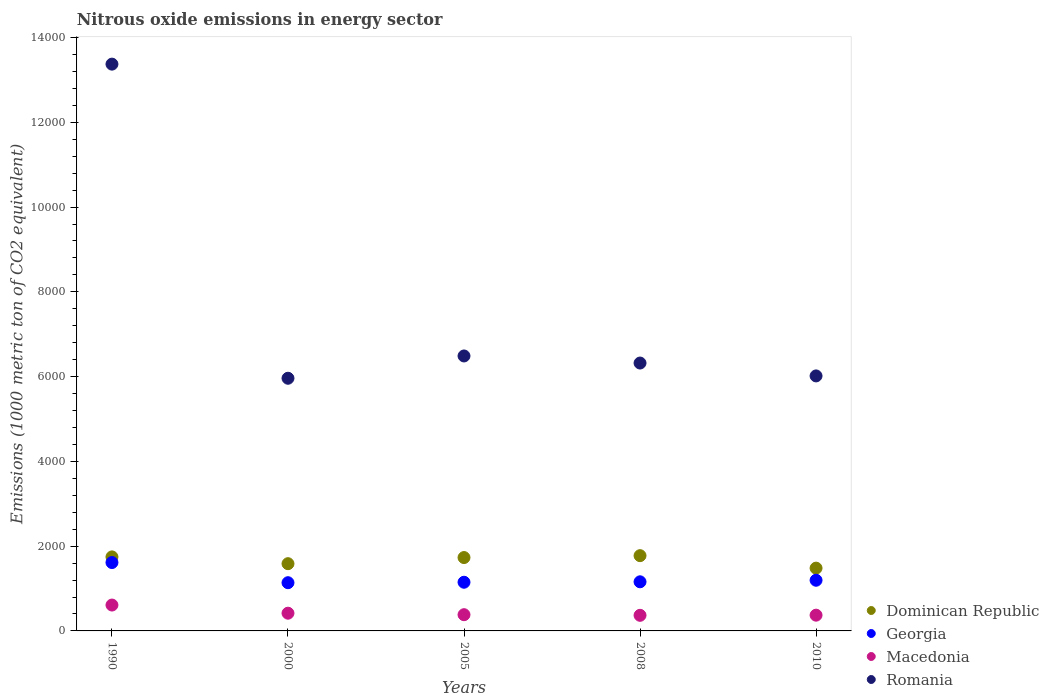What is the amount of nitrous oxide emitted in Macedonia in 2000?
Your answer should be compact. 418.3. Across all years, what is the maximum amount of nitrous oxide emitted in Macedonia?
Keep it short and to the point. 610.4. Across all years, what is the minimum amount of nitrous oxide emitted in Macedonia?
Ensure brevity in your answer.  368. In which year was the amount of nitrous oxide emitted in Georgia minimum?
Offer a very short reply. 2000. What is the total amount of nitrous oxide emitted in Macedonia in the graph?
Make the answer very short. 2151.1. What is the difference between the amount of nitrous oxide emitted in Georgia in 1990 and that in 2010?
Make the answer very short. 417.8. What is the difference between the amount of nitrous oxide emitted in Macedonia in 2000 and the amount of nitrous oxide emitted in Georgia in 2010?
Keep it short and to the point. -777.3. What is the average amount of nitrous oxide emitted in Dominican Republic per year?
Your answer should be compact. 1664.22. In the year 2010, what is the difference between the amount of nitrous oxide emitted in Georgia and amount of nitrous oxide emitted in Macedonia?
Your answer should be compact. 824. What is the ratio of the amount of nitrous oxide emitted in Georgia in 2005 to that in 2008?
Give a very brief answer. 0.99. Is the difference between the amount of nitrous oxide emitted in Georgia in 2005 and 2008 greater than the difference between the amount of nitrous oxide emitted in Macedonia in 2005 and 2008?
Keep it short and to the point. No. What is the difference between the highest and the second highest amount of nitrous oxide emitted in Romania?
Make the answer very short. 6885. What is the difference between the highest and the lowest amount of nitrous oxide emitted in Macedonia?
Make the answer very short. 242.4. In how many years, is the amount of nitrous oxide emitted in Dominican Republic greater than the average amount of nitrous oxide emitted in Dominican Republic taken over all years?
Your answer should be compact. 3. Is it the case that in every year, the sum of the amount of nitrous oxide emitted in Georgia and amount of nitrous oxide emitted in Dominican Republic  is greater than the sum of amount of nitrous oxide emitted in Macedonia and amount of nitrous oxide emitted in Romania?
Ensure brevity in your answer.  Yes. Is the amount of nitrous oxide emitted in Romania strictly less than the amount of nitrous oxide emitted in Dominican Republic over the years?
Your answer should be compact. No. How many years are there in the graph?
Your response must be concise. 5. Are the values on the major ticks of Y-axis written in scientific E-notation?
Offer a terse response. No. Does the graph contain grids?
Give a very brief answer. No. How are the legend labels stacked?
Make the answer very short. Vertical. What is the title of the graph?
Your answer should be very brief. Nitrous oxide emissions in energy sector. What is the label or title of the Y-axis?
Your response must be concise. Emissions (1000 metric ton of CO2 equivalent). What is the Emissions (1000 metric ton of CO2 equivalent) of Dominican Republic in 1990?
Your answer should be compact. 1746.5. What is the Emissions (1000 metric ton of CO2 equivalent) in Georgia in 1990?
Offer a very short reply. 1613.4. What is the Emissions (1000 metric ton of CO2 equivalent) in Macedonia in 1990?
Provide a short and direct response. 610.4. What is the Emissions (1000 metric ton of CO2 equivalent) in Romania in 1990?
Provide a short and direct response. 1.34e+04. What is the Emissions (1000 metric ton of CO2 equivalent) in Dominican Republic in 2000?
Provide a succinct answer. 1586.4. What is the Emissions (1000 metric ton of CO2 equivalent) of Georgia in 2000?
Give a very brief answer. 1137.6. What is the Emissions (1000 metric ton of CO2 equivalent) of Macedonia in 2000?
Keep it short and to the point. 418.3. What is the Emissions (1000 metric ton of CO2 equivalent) in Romania in 2000?
Provide a succinct answer. 5961.2. What is the Emissions (1000 metric ton of CO2 equivalent) in Dominican Republic in 2005?
Offer a terse response. 1731. What is the Emissions (1000 metric ton of CO2 equivalent) in Georgia in 2005?
Your answer should be very brief. 1148.6. What is the Emissions (1000 metric ton of CO2 equivalent) of Macedonia in 2005?
Provide a short and direct response. 382.8. What is the Emissions (1000 metric ton of CO2 equivalent) of Romania in 2005?
Your response must be concise. 6487.3. What is the Emissions (1000 metric ton of CO2 equivalent) of Dominican Republic in 2008?
Your answer should be very brief. 1775.7. What is the Emissions (1000 metric ton of CO2 equivalent) in Georgia in 2008?
Provide a short and direct response. 1158.8. What is the Emissions (1000 metric ton of CO2 equivalent) of Macedonia in 2008?
Offer a very short reply. 368. What is the Emissions (1000 metric ton of CO2 equivalent) in Romania in 2008?
Keep it short and to the point. 6320.1. What is the Emissions (1000 metric ton of CO2 equivalent) of Dominican Republic in 2010?
Provide a short and direct response. 1481.5. What is the Emissions (1000 metric ton of CO2 equivalent) in Georgia in 2010?
Provide a short and direct response. 1195.6. What is the Emissions (1000 metric ton of CO2 equivalent) of Macedonia in 2010?
Your answer should be very brief. 371.6. What is the Emissions (1000 metric ton of CO2 equivalent) of Romania in 2010?
Make the answer very short. 6016.4. Across all years, what is the maximum Emissions (1000 metric ton of CO2 equivalent) in Dominican Republic?
Make the answer very short. 1775.7. Across all years, what is the maximum Emissions (1000 metric ton of CO2 equivalent) of Georgia?
Your response must be concise. 1613.4. Across all years, what is the maximum Emissions (1000 metric ton of CO2 equivalent) of Macedonia?
Ensure brevity in your answer.  610.4. Across all years, what is the maximum Emissions (1000 metric ton of CO2 equivalent) in Romania?
Make the answer very short. 1.34e+04. Across all years, what is the minimum Emissions (1000 metric ton of CO2 equivalent) of Dominican Republic?
Keep it short and to the point. 1481.5. Across all years, what is the minimum Emissions (1000 metric ton of CO2 equivalent) of Georgia?
Provide a short and direct response. 1137.6. Across all years, what is the minimum Emissions (1000 metric ton of CO2 equivalent) in Macedonia?
Ensure brevity in your answer.  368. Across all years, what is the minimum Emissions (1000 metric ton of CO2 equivalent) in Romania?
Your answer should be very brief. 5961.2. What is the total Emissions (1000 metric ton of CO2 equivalent) of Dominican Republic in the graph?
Your response must be concise. 8321.1. What is the total Emissions (1000 metric ton of CO2 equivalent) in Georgia in the graph?
Offer a very short reply. 6254. What is the total Emissions (1000 metric ton of CO2 equivalent) of Macedonia in the graph?
Give a very brief answer. 2151.1. What is the total Emissions (1000 metric ton of CO2 equivalent) of Romania in the graph?
Your answer should be compact. 3.82e+04. What is the difference between the Emissions (1000 metric ton of CO2 equivalent) of Dominican Republic in 1990 and that in 2000?
Keep it short and to the point. 160.1. What is the difference between the Emissions (1000 metric ton of CO2 equivalent) of Georgia in 1990 and that in 2000?
Provide a succinct answer. 475.8. What is the difference between the Emissions (1000 metric ton of CO2 equivalent) of Macedonia in 1990 and that in 2000?
Offer a terse response. 192.1. What is the difference between the Emissions (1000 metric ton of CO2 equivalent) of Romania in 1990 and that in 2000?
Ensure brevity in your answer.  7411.1. What is the difference between the Emissions (1000 metric ton of CO2 equivalent) of Georgia in 1990 and that in 2005?
Give a very brief answer. 464.8. What is the difference between the Emissions (1000 metric ton of CO2 equivalent) in Macedonia in 1990 and that in 2005?
Give a very brief answer. 227.6. What is the difference between the Emissions (1000 metric ton of CO2 equivalent) in Romania in 1990 and that in 2005?
Give a very brief answer. 6885. What is the difference between the Emissions (1000 metric ton of CO2 equivalent) in Dominican Republic in 1990 and that in 2008?
Your response must be concise. -29.2. What is the difference between the Emissions (1000 metric ton of CO2 equivalent) in Georgia in 1990 and that in 2008?
Give a very brief answer. 454.6. What is the difference between the Emissions (1000 metric ton of CO2 equivalent) in Macedonia in 1990 and that in 2008?
Your response must be concise. 242.4. What is the difference between the Emissions (1000 metric ton of CO2 equivalent) of Romania in 1990 and that in 2008?
Offer a very short reply. 7052.2. What is the difference between the Emissions (1000 metric ton of CO2 equivalent) in Dominican Republic in 1990 and that in 2010?
Offer a terse response. 265. What is the difference between the Emissions (1000 metric ton of CO2 equivalent) in Georgia in 1990 and that in 2010?
Provide a succinct answer. 417.8. What is the difference between the Emissions (1000 metric ton of CO2 equivalent) in Macedonia in 1990 and that in 2010?
Offer a very short reply. 238.8. What is the difference between the Emissions (1000 metric ton of CO2 equivalent) of Romania in 1990 and that in 2010?
Provide a short and direct response. 7355.9. What is the difference between the Emissions (1000 metric ton of CO2 equivalent) of Dominican Republic in 2000 and that in 2005?
Keep it short and to the point. -144.6. What is the difference between the Emissions (1000 metric ton of CO2 equivalent) in Georgia in 2000 and that in 2005?
Your answer should be very brief. -11. What is the difference between the Emissions (1000 metric ton of CO2 equivalent) in Macedonia in 2000 and that in 2005?
Your answer should be very brief. 35.5. What is the difference between the Emissions (1000 metric ton of CO2 equivalent) of Romania in 2000 and that in 2005?
Provide a succinct answer. -526.1. What is the difference between the Emissions (1000 metric ton of CO2 equivalent) in Dominican Republic in 2000 and that in 2008?
Provide a succinct answer. -189.3. What is the difference between the Emissions (1000 metric ton of CO2 equivalent) in Georgia in 2000 and that in 2008?
Offer a very short reply. -21.2. What is the difference between the Emissions (1000 metric ton of CO2 equivalent) in Macedonia in 2000 and that in 2008?
Give a very brief answer. 50.3. What is the difference between the Emissions (1000 metric ton of CO2 equivalent) of Romania in 2000 and that in 2008?
Make the answer very short. -358.9. What is the difference between the Emissions (1000 metric ton of CO2 equivalent) of Dominican Republic in 2000 and that in 2010?
Provide a succinct answer. 104.9. What is the difference between the Emissions (1000 metric ton of CO2 equivalent) in Georgia in 2000 and that in 2010?
Your answer should be very brief. -58. What is the difference between the Emissions (1000 metric ton of CO2 equivalent) in Macedonia in 2000 and that in 2010?
Offer a very short reply. 46.7. What is the difference between the Emissions (1000 metric ton of CO2 equivalent) of Romania in 2000 and that in 2010?
Your answer should be compact. -55.2. What is the difference between the Emissions (1000 metric ton of CO2 equivalent) in Dominican Republic in 2005 and that in 2008?
Ensure brevity in your answer.  -44.7. What is the difference between the Emissions (1000 metric ton of CO2 equivalent) in Georgia in 2005 and that in 2008?
Your answer should be very brief. -10.2. What is the difference between the Emissions (1000 metric ton of CO2 equivalent) of Romania in 2005 and that in 2008?
Make the answer very short. 167.2. What is the difference between the Emissions (1000 metric ton of CO2 equivalent) of Dominican Republic in 2005 and that in 2010?
Your response must be concise. 249.5. What is the difference between the Emissions (1000 metric ton of CO2 equivalent) of Georgia in 2005 and that in 2010?
Offer a terse response. -47. What is the difference between the Emissions (1000 metric ton of CO2 equivalent) of Romania in 2005 and that in 2010?
Make the answer very short. 470.9. What is the difference between the Emissions (1000 metric ton of CO2 equivalent) in Dominican Republic in 2008 and that in 2010?
Provide a succinct answer. 294.2. What is the difference between the Emissions (1000 metric ton of CO2 equivalent) in Georgia in 2008 and that in 2010?
Ensure brevity in your answer.  -36.8. What is the difference between the Emissions (1000 metric ton of CO2 equivalent) in Macedonia in 2008 and that in 2010?
Offer a very short reply. -3.6. What is the difference between the Emissions (1000 metric ton of CO2 equivalent) in Romania in 2008 and that in 2010?
Provide a short and direct response. 303.7. What is the difference between the Emissions (1000 metric ton of CO2 equivalent) of Dominican Republic in 1990 and the Emissions (1000 metric ton of CO2 equivalent) of Georgia in 2000?
Your answer should be very brief. 608.9. What is the difference between the Emissions (1000 metric ton of CO2 equivalent) in Dominican Republic in 1990 and the Emissions (1000 metric ton of CO2 equivalent) in Macedonia in 2000?
Provide a succinct answer. 1328.2. What is the difference between the Emissions (1000 metric ton of CO2 equivalent) of Dominican Republic in 1990 and the Emissions (1000 metric ton of CO2 equivalent) of Romania in 2000?
Your answer should be very brief. -4214.7. What is the difference between the Emissions (1000 metric ton of CO2 equivalent) of Georgia in 1990 and the Emissions (1000 metric ton of CO2 equivalent) of Macedonia in 2000?
Provide a succinct answer. 1195.1. What is the difference between the Emissions (1000 metric ton of CO2 equivalent) in Georgia in 1990 and the Emissions (1000 metric ton of CO2 equivalent) in Romania in 2000?
Your answer should be compact. -4347.8. What is the difference between the Emissions (1000 metric ton of CO2 equivalent) of Macedonia in 1990 and the Emissions (1000 metric ton of CO2 equivalent) of Romania in 2000?
Provide a succinct answer. -5350.8. What is the difference between the Emissions (1000 metric ton of CO2 equivalent) of Dominican Republic in 1990 and the Emissions (1000 metric ton of CO2 equivalent) of Georgia in 2005?
Offer a terse response. 597.9. What is the difference between the Emissions (1000 metric ton of CO2 equivalent) of Dominican Republic in 1990 and the Emissions (1000 metric ton of CO2 equivalent) of Macedonia in 2005?
Make the answer very short. 1363.7. What is the difference between the Emissions (1000 metric ton of CO2 equivalent) of Dominican Republic in 1990 and the Emissions (1000 metric ton of CO2 equivalent) of Romania in 2005?
Make the answer very short. -4740.8. What is the difference between the Emissions (1000 metric ton of CO2 equivalent) of Georgia in 1990 and the Emissions (1000 metric ton of CO2 equivalent) of Macedonia in 2005?
Your answer should be very brief. 1230.6. What is the difference between the Emissions (1000 metric ton of CO2 equivalent) of Georgia in 1990 and the Emissions (1000 metric ton of CO2 equivalent) of Romania in 2005?
Your answer should be very brief. -4873.9. What is the difference between the Emissions (1000 metric ton of CO2 equivalent) of Macedonia in 1990 and the Emissions (1000 metric ton of CO2 equivalent) of Romania in 2005?
Keep it short and to the point. -5876.9. What is the difference between the Emissions (1000 metric ton of CO2 equivalent) in Dominican Republic in 1990 and the Emissions (1000 metric ton of CO2 equivalent) in Georgia in 2008?
Your response must be concise. 587.7. What is the difference between the Emissions (1000 metric ton of CO2 equivalent) in Dominican Republic in 1990 and the Emissions (1000 metric ton of CO2 equivalent) in Macedonia in 2008?
Provide a short and direct response. 1378.5. What is the difference between the Emissions (1000 metric ton of CO2 equivalent) in Dominican Republic in 1990 and the Emissions (1000 metric ton of CO2 equivalent) in Romania in 2008?
Your response must be concise. -4573.6. What is the difference between the Emissions (1000 metric ton of CO2 equivalent) in Georgia in 1990 and the Emissions (1000 metric ton of CO2 equivalent) in Macedonia in 2008?
Give a very brief answer. 1245.4. What is the difference between the Emissions (1000 metric ton of CO2 equivalent) of Georgia in 1990 and the Emissions (1000 metric ton of CO2 equivalent) of Romania in 2008?
Give a very brief answer. -4706.7. What is the difference between the Emissions (1000 metric ton of CO2 equivalent) of Macedonia in 1990 and the Emissions (1000 metric ton of CO2 equivalent) of Romania in 2008?
Offer a terse response. -5709.7. What is the difference between the Emissions (1000 metric ton of CO2 equivalent) in Dominican Republic in 1990 and the Emissions (1000 metric ton of CO2 equivalent) in Georgia in 2010?
Your response must be concise. 550.9. What is the difference between the Emissions (1000 metric ton of CO2 equivalent) in Dominican Republic in 1990 and the Emissions (1000 metric ton of CO2 equivalent) in Macedonia in 2010?
Make the answer very short. 1374.9. What is the difference between the Emissions (1000 metric ton of CO2 equivalent) of Dominican Republic in 1990 and the Emissions (1000 metric ton of CO2 equivalent) of Romania in 2010?
Provide a short and direct response. -4269.9. What is the difference between the Emissions (1000 metric ton of CO2 equivalent) of Georgia in 1990 and the Emissions (1000 metric ton of CO2 equivalent) of Macedonia in 2010?
Provide a succinct answer. 1241.8. What is the difference between the Emissions (1000 metric ton of CO2 equivalent) of Georgia in 1990 and the Emissions (1000 metric ton of CO2 equivalent) of Romania in 2010?
Give a very brief answer. -4403. What is the difference between the Emissions (1000 metric ton of CO2 equivalent) of Macedonia in 1990 and the Emissions (1000 metric ton of CO2 equivalent) of Romania in 2010?
Make the answer very short. -5406. What is the difference between the Emissions (1000 metric ton of CO2 equivalent) in Dominican Republic in 2000 and the Emissions (1000 metric ton of CO2 equivalent) in Georgia in 2005?
Give a very brief answer. 437.8. What is the difference between the Emissions (1000 metric ton of CO2 equivalent) of Dominican Republic in 2000 and the Emissions (1000 metric ton of CO2 equivalent) of Macedonia in 2005?
Make the answer very short. 1203.6. What is the difference between the Emissions (1000 metric ton of CO2 equivalent) in Dominican Republic in 2000 and the Emissions (1000 metric ton of CO2 equivalent) in Romania in 2005?
Provide a succinct answer. -4900.9. What is the difference between the Emissions (1000 metric ton of CO2 equivalent) in Georgia in 2000 and the Emissions (1000 metric ton of CO2 equivalent) in Macedonia in 2005?
Give a very brief answer. 754.8. What is the difference between the Emissions (1000 metric ton of CO2 equivalent) in Georgia in 2000 and the Emissions (1000 metric ton of CO2 equivalent) in Romania in 2005?
Your answer should be very brief. -5349.7. What is the difference between the Emissions (1000 metric ton of CO2 equivalent) of Macedonia in 2000 and the Emissions (1000 metric ton of CO2 equivalent) of Romania in 2005?
Make the answer very short. -6069. What is the difference between the Emissions (1000 metric ton of CO2 equivalent) of Dominican Republic in 2000 and the Emissions (1000 metric ton of CO2 equivalent) of Georgia in 2008?
Your response must be concise. 427.6. What is the difference between the Emissions (1000 metric ton of CO2 equivalent) of Dominican Republic in 2000 and the Emissions (1000 metric ton of CO2 equivalent) of Macedonia in 2008?
Keep it short and to the point. 1218.4. What is the difference between the Emissions (1000 metric ton of CO2 equivalent) of Dominican Republic in 2000 and the Emissions (1000 metric ton of CO2 equivalent) of Romania in 2008?
Provide a short and direct response. -4733.7. What is the difference between the Emissions (1000 metric ton of CO2 equivalent) in Georgia in 2000 and the Emissions (1000 metric ton of CO2 equivalent) in Macedonia in 2008?
Provide a short and direct response. 769.6. What is the difference between the Emissions (1000 metric ton of CO2 equivalent) of Georgia in 2000 and the Emissions (1000 metric ton of CO2 equivalent) of Romania in 2008?
Make the answer very short. -5182.5. What is the difference between the Emissions (1000 metric ton of CO2 equivalent) of Macedonia in 2000 and the Emissions (1000 metric ton of CO2 equivalent) of Romania in 2008?
Your response must be concise. -5901.8. What is the difference between the Emissions (1000 metric ton of CO2 equivalent) of Dominican Republic in 2000 and the Emissions (1000 metric ton of CO2 equivalent) of Georgia in 2010?
Your answer should be very brief. 390.8. What is the difference between the Emissions (1000 metric ton of CO2 equivalent) in Dominican Republic in 2000 and the Emissions (1000 metric ton of CO2 equivalent) in Macedonia in 2010?
Give a very brief answer. 1214.8. What is the difference between the Emissions (1000 metric ton of CO2 equivalent) of Dominican Republic in 2000 and the Emissions (1000 metric ton of CO2 equivalent) of Romania in 2010?
Offer a very short reply. -4430. What is the difference between the Emissions (1000 metric ton of CO2 equivalent) of Georgia in 2000 and the Emissions (1000 metric ton of CO2 equivalent) of Macedonia in 2010?
Your answer should be compact. 766. What is the difference between the Emissions (1000 metric ton of CO2 equivalent) of Georgia in 2000 and the Emissions (1000 metric ton of CO2 equivalent) of Romania in 2010?
Give a very brief answer. -4878.8. What is the difference between the Emissions (1000 metric ton of CO2 equivalent) of Macedonia in 2000 and the Emissions (1000 metric ton of CO2 equivalent) of Romania in 2010?
Your response must be concise. -5598.1. What is the difference between the Emissions (1000 metric ton of CO2 equivalent) of Dominican Republic in 2005 and the Emissions (1000 metric ton of CO2 equivalent) of Georgia in 2008?
Provide a succinct answer. 572.2. What is the difference between the Emissions (1000 metric ton of CO2 equivalent) of Dominican Republic in 2005 and the Emissions (1000 metric ton of CO2 equivalent) of Macedonia in 2008?
Your answer should be compact. 1363. What is the difference between the Emissions (1000 metric ton of CO2 equivalent) of Dominican Republic in 2005 and the Emissions (1000 metric ton of CO2 equivalent) of Romania in 2008?
Make the answer very short. -4589.1. What is the difference between the Emissions (1000 metric ton of CO2 equivalent) in Georgia in 2005 and the Emissions (1000 metric ton of CO2 equivalent) in Macedonia in 2008?
Offer a terse response. 780.6. What is the difference between the Emissions (1000 metric ton of CO2 equivalent) of Georgia in 2005 and the Emissions (1000 metric ton of CO2 equivalent) of Romania in 2008?
Give a very brief answer. -5171.5. What is the difference between the Emissions (1000 metric ton of CO2 equivalent) in Macedonia in 2005 and the Emissions (1000 metric ton of CO2 equivalent) in Romania in 2008?
Your response must be concise. -5937.3. What is the difference between the Emissions (1000 metric ton of CO2 equivalent) of Dominican Republic in 2005 and the Emissions (1000 metric ton of CO2 equivalent) of Georgia in 2010?
Ensure brevity in your answer.  535.4. What is the difference between the Emissions (1000 metric ton of CO2 equivalent) in Dominican Republic in 2005 and the Emissions (1000 metric ton of CO2 equivalent) in Macedonia in 2010?
Your response must be concise. 1359.4. What is the difference between the Emissions (1000 metric ton of CO2 equivalent) in Dominican Republic in 2005 and the Emissions (1000 metric ton of CO2 equivalent) in Romania in 2010?
Your answer should be very brief. -4285.4. What is the difference between the Emissions (1000 metric ton of CO2 equivalent) of Georgia in 2005 and the Emissions (1000 metric ton of CO2 equivalent) of Macedonia in 2010?
Provide a short and direct response. 777. What is the difference between the Emissions (1000 metric ton of CO2 equivalent) of Georgia in 2005 and the Emissions (1000 metric ton of CO2 equivalent) of Romania in 2010?
Your response must be concise. -4867.8. What is the difference between the Emissions (1000 metric ton of CO2 equivalent) of Macedonia in 2005 and the Emissions (1000 metric ton of CO2 equivalent) of Romania in 2010?
Offer a terse response. -5633.6. What is the difference between the Emissions (1000 metric ton of CO2 equivalent) in Dominican Republic in 2008 and the Emissions (1000 metric ton of CO2 equivalent) in Georgia in 2010?
Offer a terse response. 580.1. What is the difference between the Emissions (1000 metric ton of CO2 equivalent) of Dominican Republic in 2008 and the Emissions (1000 metric ton of CO2 equivalent) of Macedonia in 2010?
Give a very brief answer. 1404.1. What is the difference between the Emissions (1000 metric ton of CO2 equivalent) of Dominican Republic in 2008 and the Emissions (1000 metric ton of CO2 equivalent) of Romania in 2010?
Your answer should be very brief. -4240.7. What is the difference between the Emissions (1000 metric ton of CO2 equivalent) of Georgia in 2008 and the Emissions (1000 metric ton of CO2 equivalent) of Macedonia in 2010?
Your response must be concise. 787.2. What is the difference between the Emissions (1000 metric ton of CO2 equivalent) in Georgia in 2008 and the Emissions (1000 metric ton of CO2 equivalent) in Romania in 2010?
Provide a succinct answer. -4857.6. What is the difference between the Emissions (1000 metric ton of CO2 equivalent) of Macedonia in 2008 and the Emissions (1000 metric ton of CO2 equivalent) of Romania in 2010?
Offer a terse response. -5648.4. What is the average Emissions (1000 metric ton of CO2 equivalent) in Dominican Republic per year?
Offer a very short reply. 1664.22. What is the average Emissions (1000 metric ton of CO2 equivalent) in Georgia per year?
Your response must be concise. 1250.8. What is the average Emissions (1000 metric ton of CO2 equivalent) of Macedonia per year?
Your answer should be compact. 430.22. What is the average Emissions (1000 metric ton of CO2 equivalent) in Romania per year?
Offer a terse response. 7631.46. In the year 1990, what is the difference between the Emissions (1000 metric ton of CO2 equivalent) of Dominican Republic and Emissions (1000 metric ton of CO2 equivalent) of Georgia?
Provide a short and direct response. 133.1. In the year 1990, what is the difference between the Emissions (1000 metric ton of CO2 equivalent) of Dominican Republic and Emissions (1000 metric ton of CO2 equivalent) of Macedonia?
Your response must be concise. 1136.1. In the year 1990, what is the difference between the Emissions (1000 metric ton of CO2 equivalent) in Dominican Republic and Emissions (1000 metric ton of CO2 equivalent) in Romania?
Keep it short and to the point. -1.16e+04. In the year 1990, what is the difference between the Emissions (1000 metric ton of CO2 equivalent) of Georgia and Emissions (1000 metric ton of CO2 equivalent) of Macedonia?
Keep it short and to the point. 1003. In the year 1990, what is the difference between the Emissions (1000 metric ton of CO2 equivalent) of Georgia and Emissions (1000 metric ton of CO2 equivalent) of Romania?
Provide a succinct answer. -1.18e+04. In the year 1990, what is the difference between the Emissions (1000 metric ton of CO2 equivalent) of Macedonia and Emissions (1000 metric ton of CO2 equivalent) of Romania?
Offer a very short reply. -1.28e+04. In the year 2000, what is the difference between the Emissions (1000 metric ton of CO2 equivalent) of Dominican Republic and Emissions (1000 metric ton of CO2 equivalent) of Georgia?
Provide a short and direct response. 448.8. In the year 2000, what is the difference between the Emissions (1000 metric ton of CO2 equivalent) in Dominican Republic and Emissions (1000 metric ton of CO2 equivalent) in Macedonia?
Make the answer very short. 1168.1. In the year 2000, what is the difference between the Emissions (1000 metric ton of CO2 equivalent) of Dominican Republic and Emissions (1000 metric ton of CO2 equivalent) of Romania?
Keep it short and to the point. -4374.8. In the year 2000, what is the difference between the Emissions (1000 metric ton of CO2 equivalent) of Georgia and Emissions (1000 metric ton of CO2 equivalent) of Macedonia?
Make the answer very short. 719.3. In the year 2000, what is the difference between the Emissions (1000 metric ton of CO2 equivalent) in Georgia and Emissions (1000 metric ton of CO2 equivalent) in Romania?
Offer a terse response. -4823.6. In the year 2000, what is the difference between the Emissions (1000 metric ton of CO2 equivalent) of Macedonia and Emissions (1000 metric ton of CO2 equivalent) of Romania?
Your answer should be very brief. -5542.9. In the year 2005, what is the difference between the Emissions (1000 metric ton of CO2 equivalent) in Dominican Republic and Emissions (1000 metric ton of CO2 equivalent) in Georgia?
Your response must be concise. 582.4. In the year 2005, what is the difference between the Emissions (1000 metric ton of CO2 equivalent) in Dominican Republic and Emissions (1000 metric ton of CO2 equivalent) in Macedonia?
Provide a short and direct response. 1348.2. In the year 2005, what is the difference between the Emissions (1000 metric ton of CO2 equivalent) of Dominican Republic and Emissions (1000 metric ton of CO2 equivalent) of Romania?
Your answer should be very brief. -4756.3. In the year 2005, what is the difference between the Emissions (1000 metric ton of CO2 equivalent) in Georgia and Emissions (1000 metric ton of CO2 equivalent) in Macedonia?
Provide a short and direct response. 765.8. In the year 2005, what is the difference between the Emissions (1000 metric ton of CO2 equivalent) of Georgia and Emissions (1000 metric ton of CO2 equivalent) of Romania?
Keep it short and to the point. -5338.7. In the year 2005, what is the difference between the Emissions (1000 metric ton of CO2 equivalent) of Macedonia and Emissions (1000 metric ton of CO2 equivalent) of Romania?
Your response must be concise. -6104.5. In the year 2008, what is the difference between the Emissions (1000 metric ton of CO2 equivalent) of Dominican Republic and Emissions (1000 metric ton of CO2 equivalent) of Georgia?
Give a very brief answer. 616.9. In the year 2008, what is the difference between the Emissions (1000 metric ton of CO2 equivalent) in Dominican Republic and Emissions (1000 metric ton of CO2 equivalent) in Macedonia?
Provide a succinct answer. 1407.7. In the year 2008, what is the difference between the Emissions (1000 metric ton of CO2 equivalent) in Dominican Republic and Emissions (1000 metric ton of CO2 equivalent) in Romania?
Your answer should be very brief. -4544.4. In the year 2008, what is the difference between the Emissions (1000 metric ton of CO2 equivalent) in Georgia and Emissions (1000 metric ton of CO2 equivalent) in Macedonia?
Your response must be concise. 790.8. In the year 2008, what is the difference between the Emissions (1000 metric ton of CO2 equivalent) in Georgia and Emissions (1000 metric ton of CO2 equivalent) in Romania?
Provide a short and direct response. -5161.3. In the year 2008, what is the difference between the Emissions (1000 metric ton of CO2 equivalent) in Macedonia and Emissions (1000 metric ton of CO2 equivalent) in Romania?
Ensure brevity in your answer.  -5952.1. In the year 2010, what is the difference between the Emissions (1000 metric ton of CO2 equivalent) in Dominican Republic and Emissions (1000 metric ton of CO2 equivalent) in Georgia?
Provide a short and direct response. 285.9. In the year 2010, what is the difference between the Emissions (1000 metric ton of CO2 equivalent) of Dominican Republic and Emissions (1000 metric ton of CO2 equivalent) of Macedonia?
Give a very brief answer. 1109.9. In the year 2010, what is the difference between the Emissions (1000 metric ton of CO2 equivalent) of Dominican Republic and Emissions (1000 metric ton of CO2 equivalent) of Romania?
Your answer should be very brief. -4534.9. In the year 2010, what is the difference between the Emissions (1000 metric ton of CO2 equivalent) of Georgia and Emissions (1000 metric ton of CO2 equivalent) of Macedonia?
Keep it short and to the point. 824. In the year 2010, what is the difference between the Emissions (1000 metric ton of CO2 equivalent) of Georgia and Emissions (1000 metric ton of CO2 equivalent) of Romania?
Your answer should be very brief. -4820.8. In the year 2010, what is the difference between the Emissions (1000 metric ton of CO2 equivalent) in Macedonia and Emissions (1000 metric ton of CO2 equivalent) in Romania?
Give a very brief answer. -5644.8. What is the ratio of the Emissions (1000 metric ton of CO2 equivalent) in Dominican Republic in 1990 to that in 2000?
Your response must be concise. 1.1. What is the ratio of the Emissions (1000 metric ton of CO2 equivalent) of Georgia in 1990 to that in 2000?
Provide a succinct answer. 1.42. What is the ratio of the Emissions (1000 metric ton of CO2 equivalent) in Macedonia in 1990 to that in 2000?
Provide a short and direct response. 1.46. What is the ratio of the Emissions (1000 metric ton of CO2 equivalent) of Romania in 1990 to that in 2000?
Give a very brief answer. 2.24. What is the ratio of the Emissions (1000 metric ton of CO2 equivalent) of Dominican Republic in 1990 to that in 2005?
Provide a succinct answer. 1.01. What is the ratio of the Emissions (1000 metric ton of CO2 equivalent) in Georgia in 1990 to that in 2005?
Make the answer very short. 1.4. What is the ratio of the Emissions (1000 metric ton of CO2 equivalent) of Macedonia in 1990 to that in 2005?
Keep it short and to the point. 1.59. What is the ratio of the Emissions (1000 metric ton of CO2 equivalent) of Romania in 1990 to that in 2005?
Provide a short and direct response. 2.06. What is the ratio of the Emissions (1000 metric ton of CO2 equivalent) of Dominican Republic in 1990 to that in 2008?
Offer a very short reply. 0.98. What is the ratio of the Emissions (1000 metric ton of CO2 equivalent) of Georgia in 1990 to that in 2008?
Your response must be concise. 1.39. What is the ratio of the Emissions (1000 metric ton of CO2 equivalent) in Macedonia in 1990 to that in 2008?
Your response must be concise. 1.66. What is the ratio of the Emissions (1000 metric ton of CO2 equivalent) of Romania in 1990 to that in 2008?
Keep it short and to the point. 2.12. What is the ratio of the Emissions (1000 metric ton of CO2 equivalent) in Dominican Republic in 1990 to that in 2010?
Give a very brief answer. 1.18. What is the ratio of the Emissions (1000 metric ton of CO2 equivalent) of Georgia in 1990 to that in 2010?
Ensure brevity in your answer.  1.35. What is the ratio of the Emissions (1000 metric ton of CO2 equivalent) of Macedonia in 1990 to that in 2010?
Give a very brief answer. 1.64. What is the ratio of the Emissions (1000 metric ton of CO2 equivalent) in Romania in 1990 to that in 2010?
Ensure brevity in your answer.  2.22. What is the ratio of the Emissions (1000 metric ton of CO2 equivalent) in Dominican Republic in 2000 to that in 2005?
Your answer should be very brief. 0.92. What is the ratio of the Emissions (1000 metric ton of CO2 equivalent) of Macedonia in 2000 to that in 2005?
Offer a very short reply. 1.09. What is the ratio of the Emissions (1000 metric ton of CO2 equivalent) of Romania in 2000 to that in 2005?
Your answer should be very brief. 0.92. What is the ratio of the Emissions (1000 metric ton of CO2 equivalent) of Dominican Republic in 2000 to that in 2008?
Provide a short and direct response. 0.89. What is the ratio of the Emissions (1000 metric ton of CO2 equivalent) in Georgia in 2000 to that in 2008?
Provide a short and direct response. 0.98. What is the ratio of the Emissions (1000 metric ton of CO2 equivalent) of Macedonia in 2000 to that in 2008?
Provide a succinct answer. 1.14. What is the ratio of the Emissions (1000 metric ton of CO2 equivalent) of Romania in 2000 to that in 2008?
Keep it short and to the point. 0.94. What is the ratio of the Emissions (1000 metric ton of CO2 equivalent) in Dominican Republic in 2000 to that in 2010?
Keep it short and to the point. 1.07. What is the ratio of the Emissions (1000 metric ton of CO2 equivalent) in Georgia in 2000 to that in 2010?
Make the answer very short. 0.95. What is the ratio of the Emissions (1000 metric ton of CO2 equivalent) in Macedonia in 2000 to that in 2010?
Offer a very short reply. 1.13. What is the ratio of the Emissions (1000 metric ton of CO2 equivalent) of Romania in 2000 to that in 2010?
Your response must be concise. 0.99. What is the ratio of the Emissions (1000 metric ton of CO2 equivalent) of Dominican Republic in 2005 to that in 2008?
Your response must be concise. 0.97. What is the ratio of the Emissions (1000 metric ton of CO2 equivalent) of Macedonia in 2005 to that in 2008?
Keep it short and to the point. 1.04. What is the ratio of the Emissions (1000 metric ton of CO2 equivalent) of Romania in 2005 to that in 2008?
Offer a terse response. 1.03. What is the ratio of the Emissions (1000 metric ton of CO2 equivalent) of Dominican Republic in 2005 to that in 2010?
Ensure brevity in your answer.  1.17. What is the ratio of the Emissions (1000 metric ton of CO2 equivalent) of Georgia in 2005 to that in 2010?
Make the answer very short. 0.96. What is the ratio of the Emissions (1000 metric ton of CO2 equivalent) in Macedonia in 2005 to that in 2010?
Provide a succinct answer. 1.03. What is the ratio of the Emissions (1000 metric ton of CO2 equivalent) in Romania in 2005 to that in 2010?
Make the answer very short. 1.08. What is the ratio of the Emissions (1000 metric ton of CO2 equivalent) of Dominican Republic in 2008 to that in 2010?
Offer a very short reply. 1.2. What is the ratio of the Emissions (1000 metric ton of CO2 equivalent) in Georgia in 2008 to that in 2010?
Give a very brief answer. 0.97. What is the ratio of the Emissions (1000 metric ton of CO2 equivalent) in Macedonia in 2008 to that in 2010?
Offer a terse response. 0.99. What is the ratio of the Emissions (1000 metric ton of CO2 equivalent) of Romania in 2008 to that in 2010?
Give a very brief answer. 1.05. What is the difference between the highest and the second highest Emissions (1000 metric ton of CO2 equivalent) of Dominican Republic?
Your answer should be very brief. 29.2. What is the difference between the highest and the second highest Emissions (1000 metric ton of CO2 equivalent) of Georgia?
Your answer should be very brief. 417.8. What is the difference between the highest and the second highest Emissions (1000 metric ton of CO2 equivalent) of Macedonia?
Provide a short and direct response. 192.1. What is the difference between the highest and the second highest Emissions (1000 metric ton of CO2 equivalent) in Romania?
Offer a terse response. 6885. What is the difference between the highest and the lowest Emissions (1000 metric ton of CO2 equivalent) of Dominican Republic?
Provide a succinct answer. 294.2. What is the difference between the highest and the lowest Emissions (1000 metric ton of CO2 equivalent) of Georgia?
Your response must be concise. 475.8. What is the difference between the highest and the lowest Emissions (1000 metric ton of CO2 equivalent) in Macedonia?
Your answer should be very brief. 242.4. What is the difference between the highest and the lowest Emissions (1000 metric ton of CO2 equivalent) in Romania?
Give a very brief answer. 7411.1. 